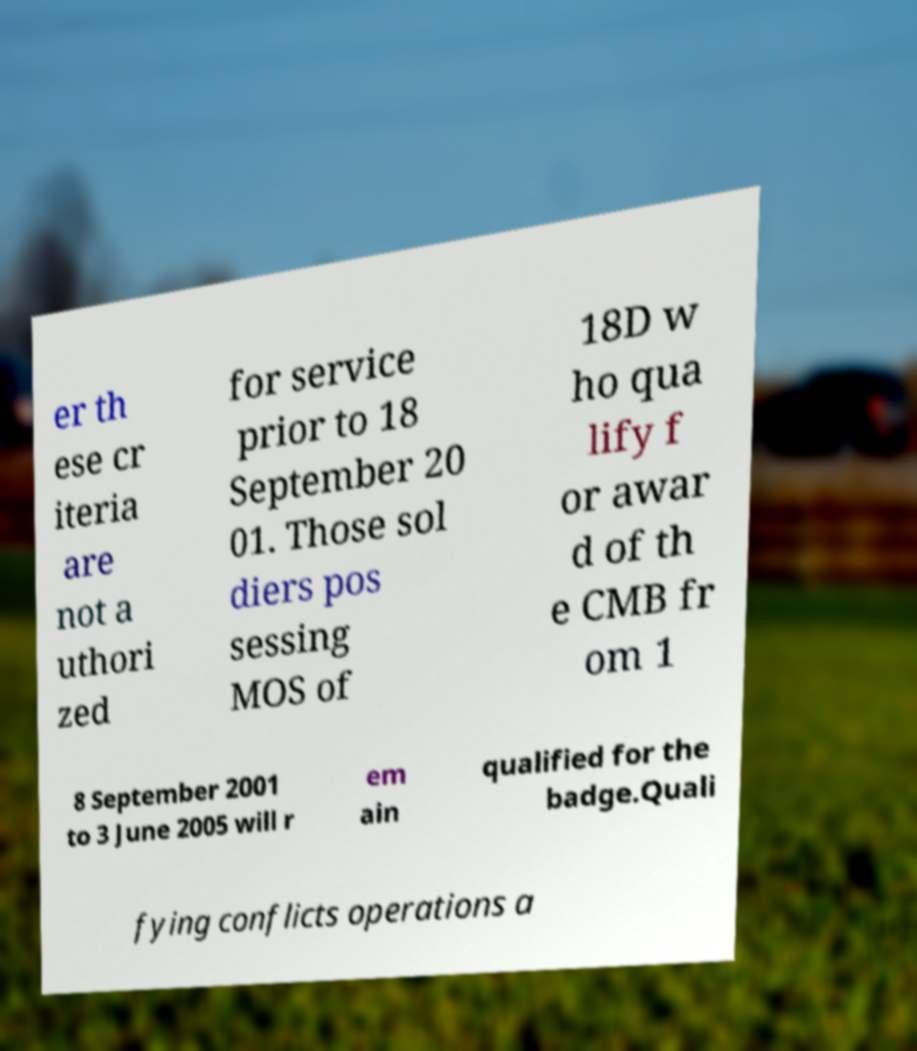Can you accurately transcribe the text from the provided image for me? er th ese cr iteria are not a uthori zed for service prior to 18 September 20 01. Those sol diers pos sessing MOS of 18D w ho qua lify f or awar d of th e CMB fr om 1 8 September 2001 to 3 June 2005 will r em ain qualified for the badge.Quali fying conflicts operations a 